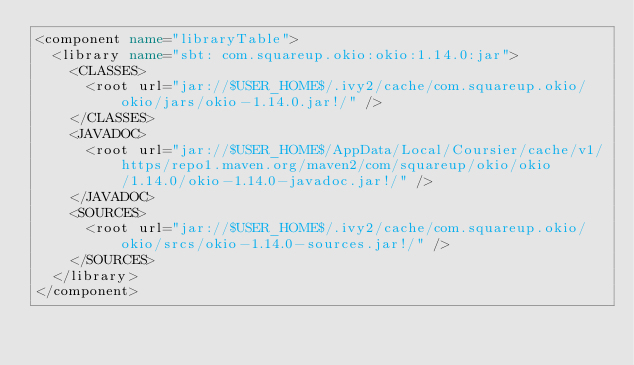<code> <loc_0><loc_0><loc_500><loc_500><_XML_><component name="libraryTable">
  <library name="sbt: com.squareup.okio:okio:1.14.0:jar">
    <CLASSES>
      <root url="jar://$USER_HOME$/.ivy2/cache/com.squareup.okio/okio/jars/okio-1.14.0.jar!/" />
    </CLASSES>
    <JAVADOC>
      <root url="jar://$USER_HOME$/AppData/Local/Coursier/cache/v1/https/repo1.maven.org/maven2/com/squareup/okio/okio/1.14.0/okio-1.14.0-javadoc.jar!/" />
    </JAVADOC>
    <SOURCES>
      <root url="jar://$USER_HOME$/.ivy2/cache/com.squareup.okio/okio/srcs/okio-1.14.0-sources.jar!/" />
    </SOURCES>
  </library>
</component></code> 